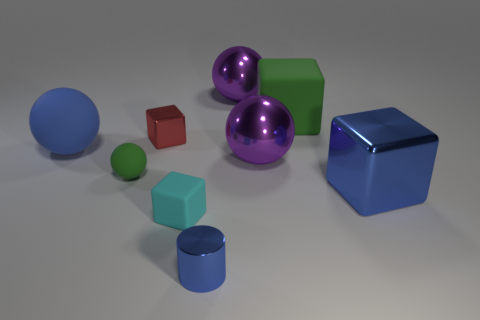Add 1 big red metal spheres. How many objects exist? 10 Subtract all cylinders. How many objects are left? 8 Subtract 0 cyan spheres. How many objects are left? 9 Subtract all blocks. Subtract all big purple metal cylinders. How many objects are left? 5 Add 8 tiny balls. How many tiny balls are left? 9 Add 3 small gray blocks. How many small gray blocks exist? 3 